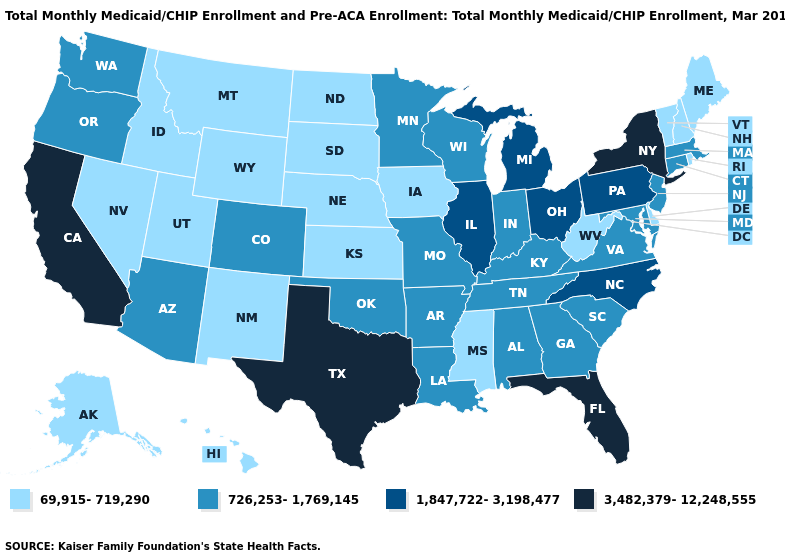What is the value of New York?
Concise answer only. 3,482,379-12,248,555. Does Ohio have a higher value than Texas?
Short answer required. No. Name the states that have a value in the range 3,482,379-12,248,555?
Be succinct. California, Florida, New York, Texas. What is the value of Maryland?
Give a very brief answer. 726,253-1,769,145. What is the highest value in the USA?
Concise answer only. 3,482,379-12,248,555. Does Colorado have the same value as Wyoming?
Keep it brief. No. What is the value of Vermont?
Write a very short answer. 69,915-719,290. What is the value of Minnesota?
Be succinct. 726,253-1,769,145. Does Ohio have the lowest value in the USA?
Write a very short answer. No. Among the states that border Kentucky , does Ohio have the lowest value?
Write a very short answer. No. Name the states that have a value in the range 3,482,379-12,248,555?
Concise answer only. California, Florida, New York, Texas. Which states have the highest value in the USA?
Short answer required. California, Florida, New York, Texas. Name the states that have a value in the range 3,482,379-12,248,555?
Concise answer only. California, Florida, New York, Texas. 